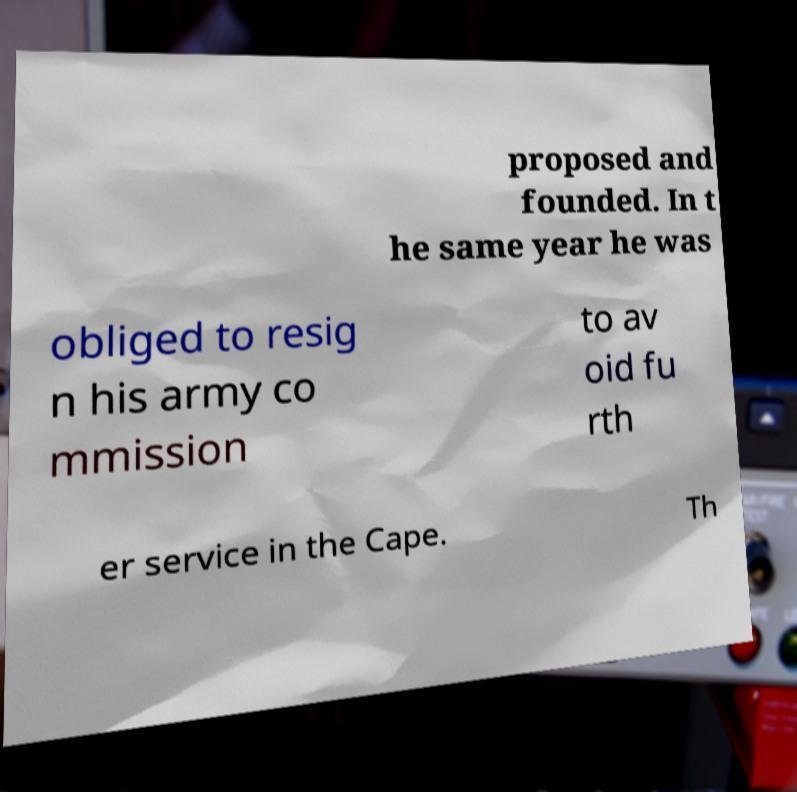Could you assist in decoding the text presented in this image and type it out clearly? proposed and founded. In t he same year he was obliged to resig n his army co mmission to av oid fu rth er service in the Cape. Th 